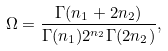<formula> <loc_0><loc_0><loc_500><loc_500>\Omega = \frac { \Gamma ( n _ { 1 } + 2 n _ { 2 } ) } { \Gamma ( n _ { 1 } ) 2 ^ { n _ { 2 } } \Gamma ( 2 n _ { 2 } ) } ,</formula> 